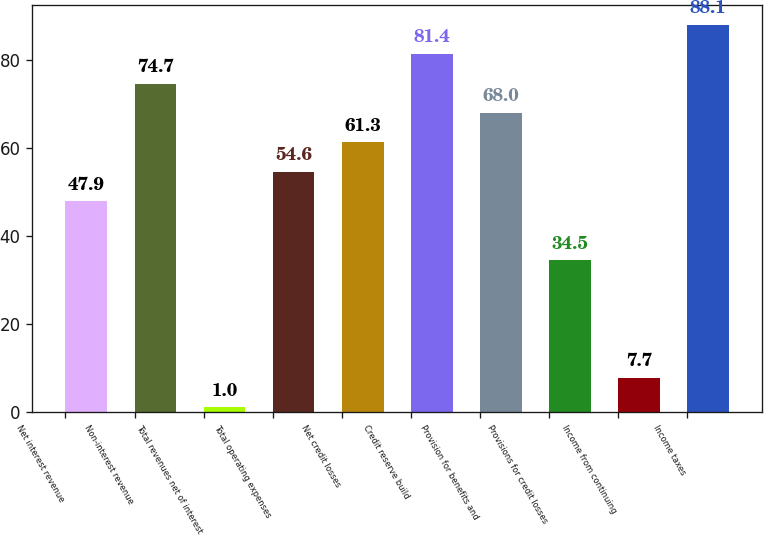Convert chart. <chart><loc_0><loc_0><loc_500><loc_500><bar_chart><fcel>Net interest revenue<fcel>Non-interest revenue<fcel>Total revenues net of interest<fcel>Total operating expenses<fcel>Net credit losses<fcel>Credit reserve build<fcel>Provision for benefits and<fcel>Provisions for credit losses<fcel>Income from continuing<fcel>Income taxes<nl><fcel>47.9<fcel>74.7<fcel>1<fcel>54.6<fcel>61.3<fcel>81.4<fcel>68<fcel>34.5<fcel>7.7<fcel>88.1<nl></chart> 